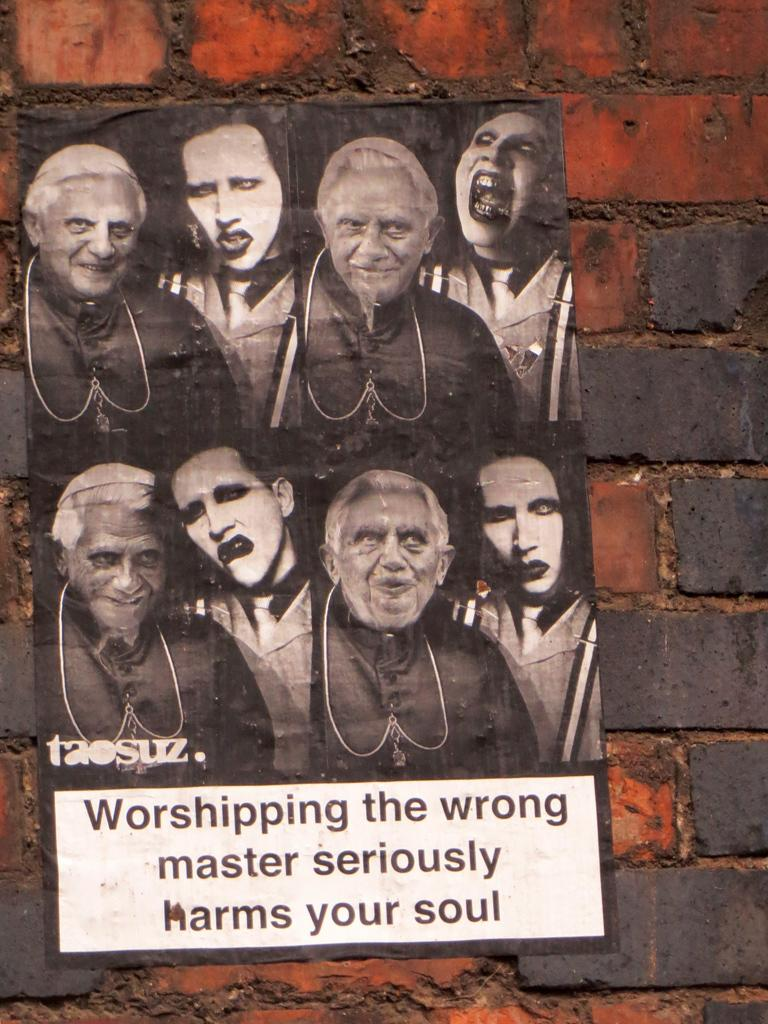What is on the wall in the image? There is a poster on the wall in the image. Where is the playground located in the image? There is no playground present in the image; it only features a poster on the wall. What type of hat is the person wearing in the image? There is no person or hat present in the image; it only features a poster on the wall. 